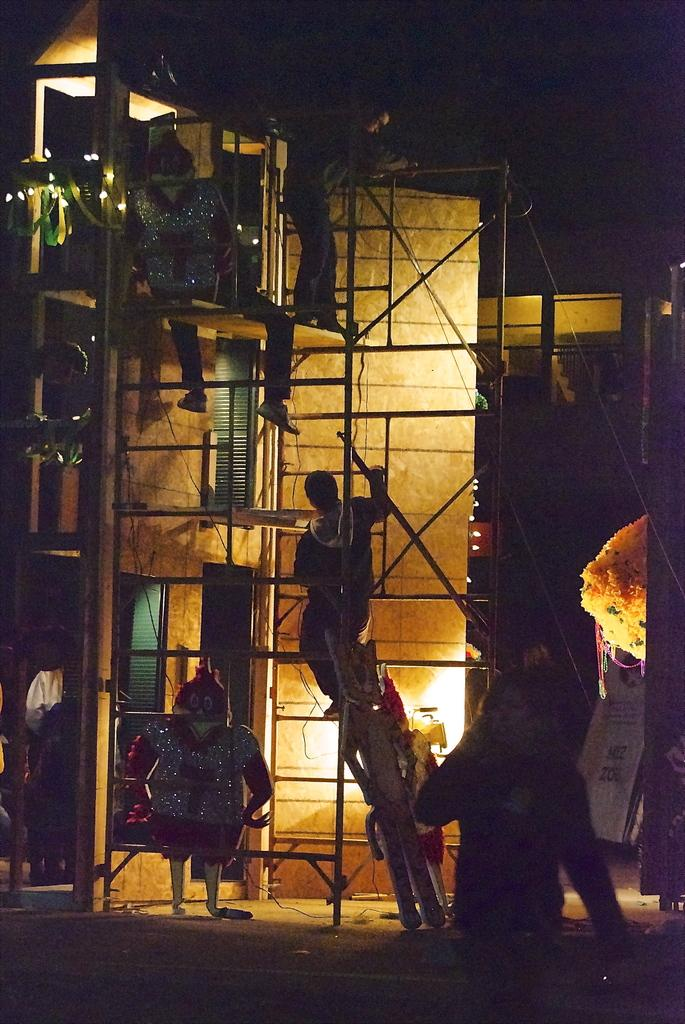Who or what can be seen in the image? There are people in the image. What type of structure is visible in the image? There is a building in the image. How many elbows can be seen in the image? There is no mention of elbows in the provided facts, so it is impossible to determine the number of elbows in the image. 